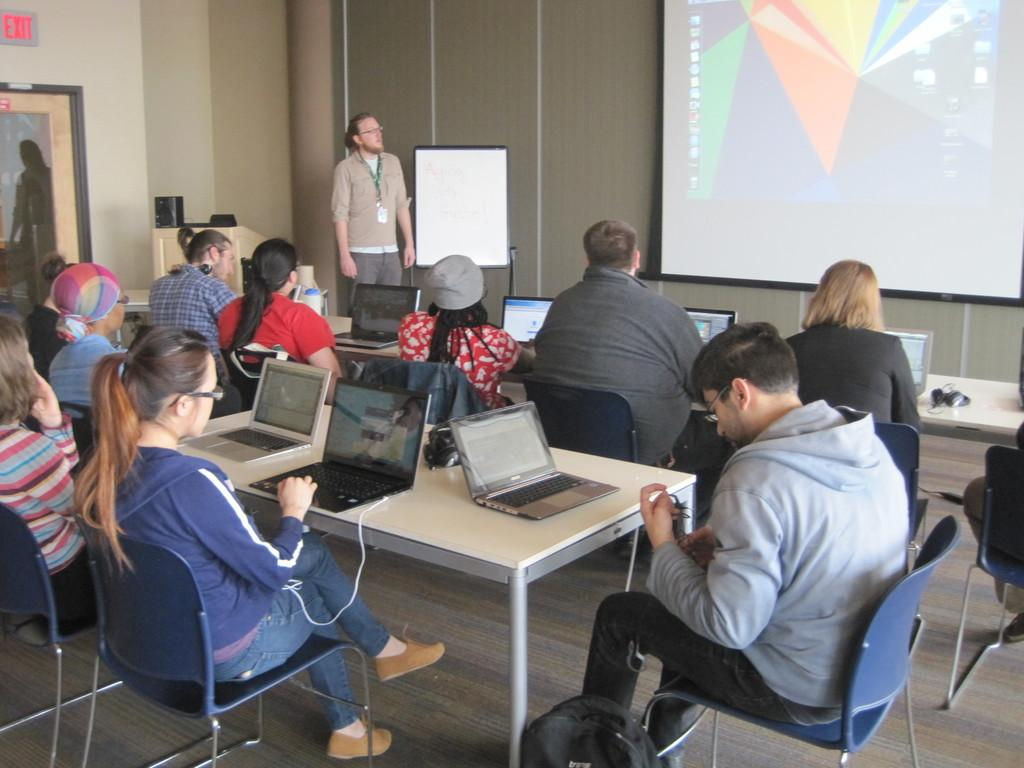How many people are in the image? There are people in the image, but the exact number is not specified. What is the position of one of the men in the image? One man is standing in the image. What are the other people doing in the image? The rest of the people are sitting on chairs in the image. What electronic devices can be seen in the image? There are laptops on different tables in the image. What is the purpose of the projector screen in the image? The projector screen in the image suggests that a presentation or display is taking place. How many snakes are slithering on the projector screen in the image? There are no snakes present in the image, and therefore none can be seen on the projector screen. 